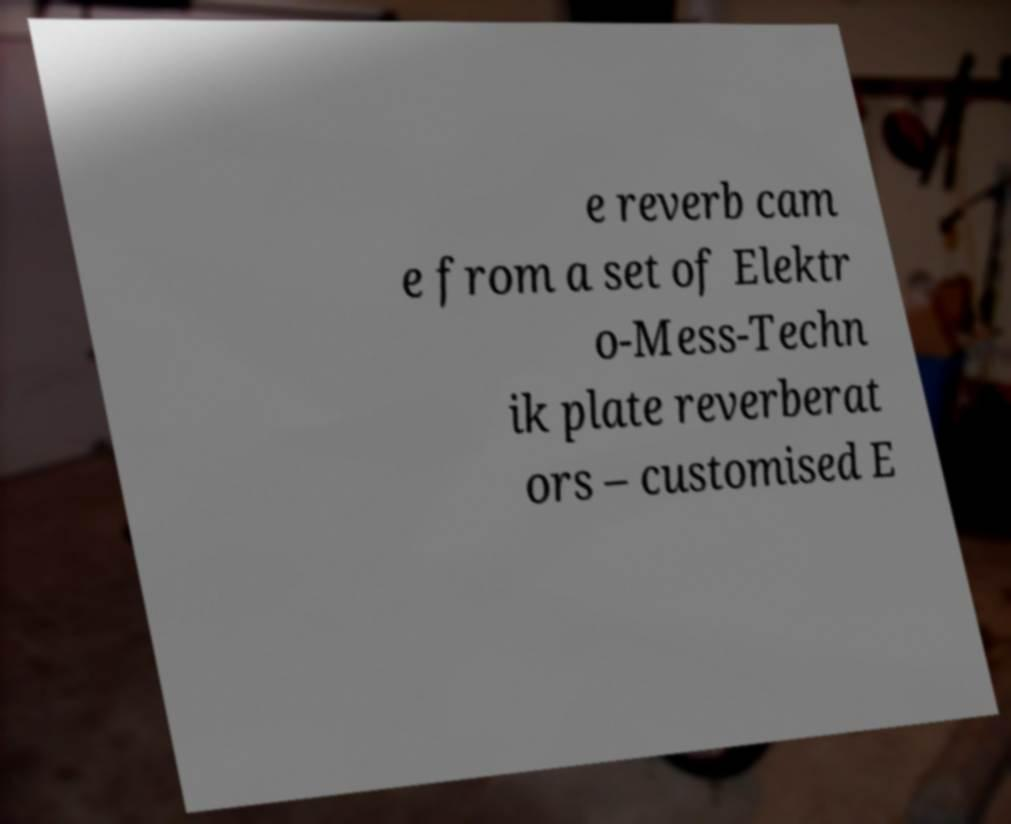What messages or text are displayed in this image? I need them in a readable, typed format. e reverb cam e from a set of Elektr o-Mess-Techn ik plate reverberat ors – customised E 